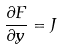<formula> <loc_0><loc_0><loc_500><loc_500>\frac { \partial F } { \partial y } = J</formula> 